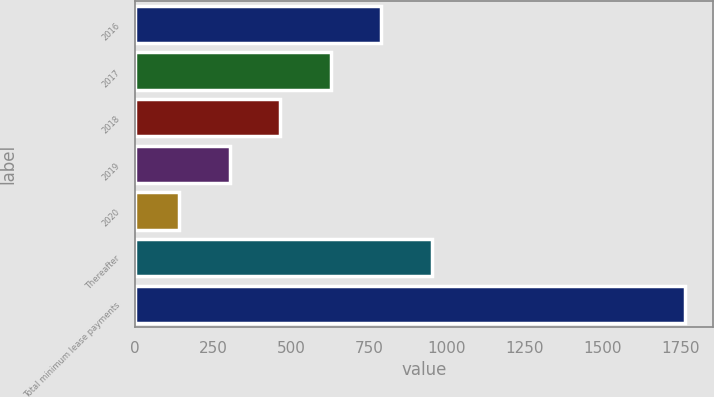Convert chart to OTSL. <chart><loc_0><loc_0><loc_500><loc_500><bar_chart><fcel>2016<fcel>2017<fcel>2018<fcel>2019<fcel>2020<fcel>Thereafter<fcel>Total minimum lease payments<nl><fcel>790.4<fcel>627.8<fcel>465.2<fcel>302.6<fcel>140<fcel>953<fcel>1766<nl></chart> 